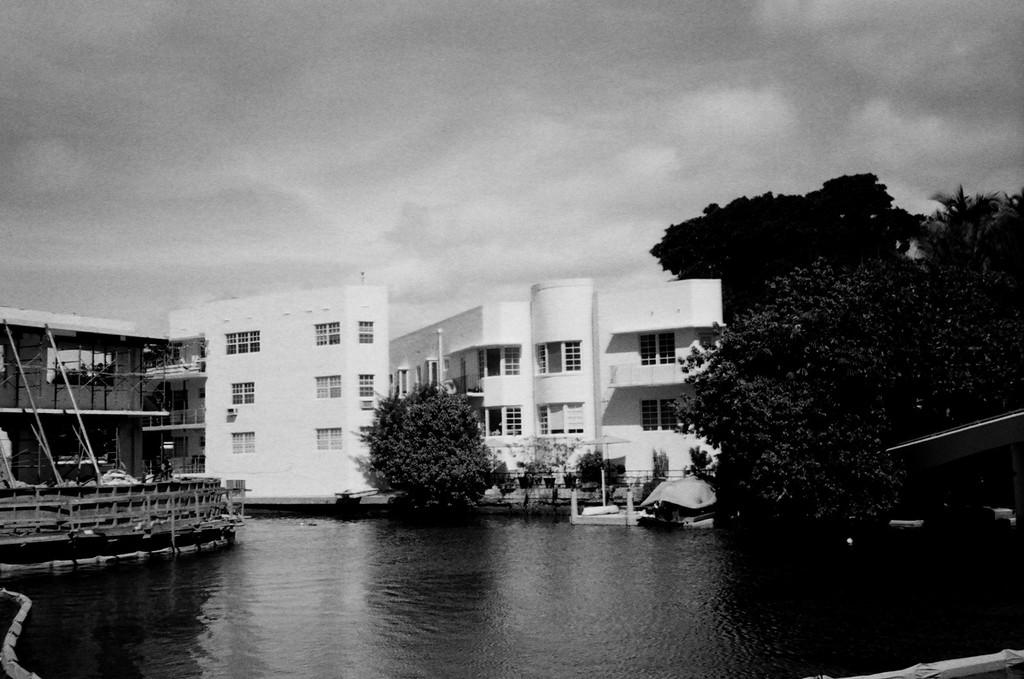What is the image is in color or black and white? The image is black and white. What can be seen in the image besides the trees and buildings in the background? There is water visible in the image. What is the condition of the sky in the image? The sky is cloudy in the image. What is the price of the potato in the image? There is no potato present in the image, so it is not possible to determine its price. How many hours of sleep can be seen in the image? There is no reference to sleep or any sleeping figures in the image. 